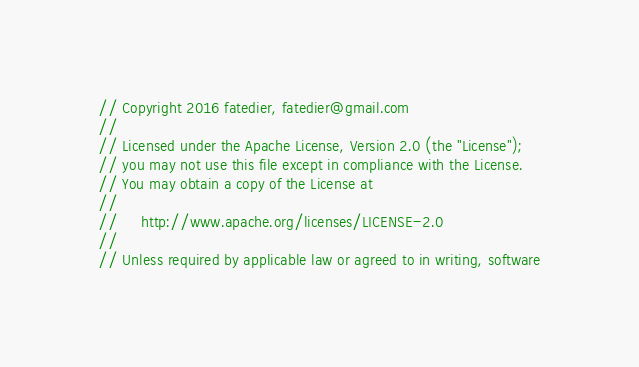Convert code to text. <code><loc_0><loc_0><loc_500><loc_500><_Go_>// Copyright 2016 fatedier, fatedier@gmail.com
//
// Licensed under the Apache License, Version 2.0 (the "License");
// you may not use this file except in compliance with the License.
// You may obtain a copy of the License at
//
//     http://www.apache.org/licenses/LICENSE-2.0
//
// Unless required by applicable law or agreed to in writing, software</code> 